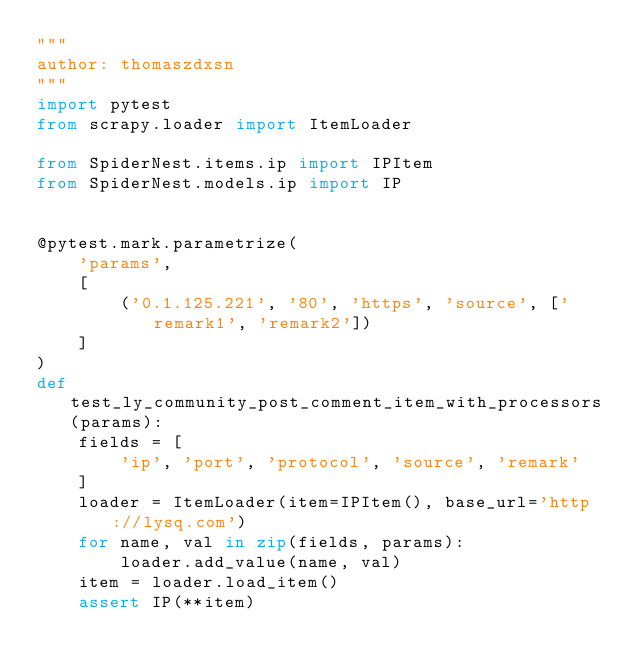Convert code to text. <code><loc_0><loc_0><loc_500><loc_500><_Python_>"""
author: thomaszdxsn
"""
import pytest
from scrapy.loader import ItemLoader

from SpiderNest.items.ip import IPItem
from SpiderNest.models.ip import IP


@pytest.mark.parametrize(
    'params',
    [
        ('0.1.125.221', '80', 'https', 'source', ['remark1', 'remark2'])
    ]
)
def test_ly_community_post_comment_item_with_processors(params):
    fields = [
        'ip', 'port', 'protocol', 'source', 'remark'
    ]
    loader = ItemLoader(item=IPItem(), base_url='http://lysq.com')
    for name, val in zip(fields, params):
        loader.add_value(name, val)
    item = loader.load_item()
    assert IP(**item)
</code> 